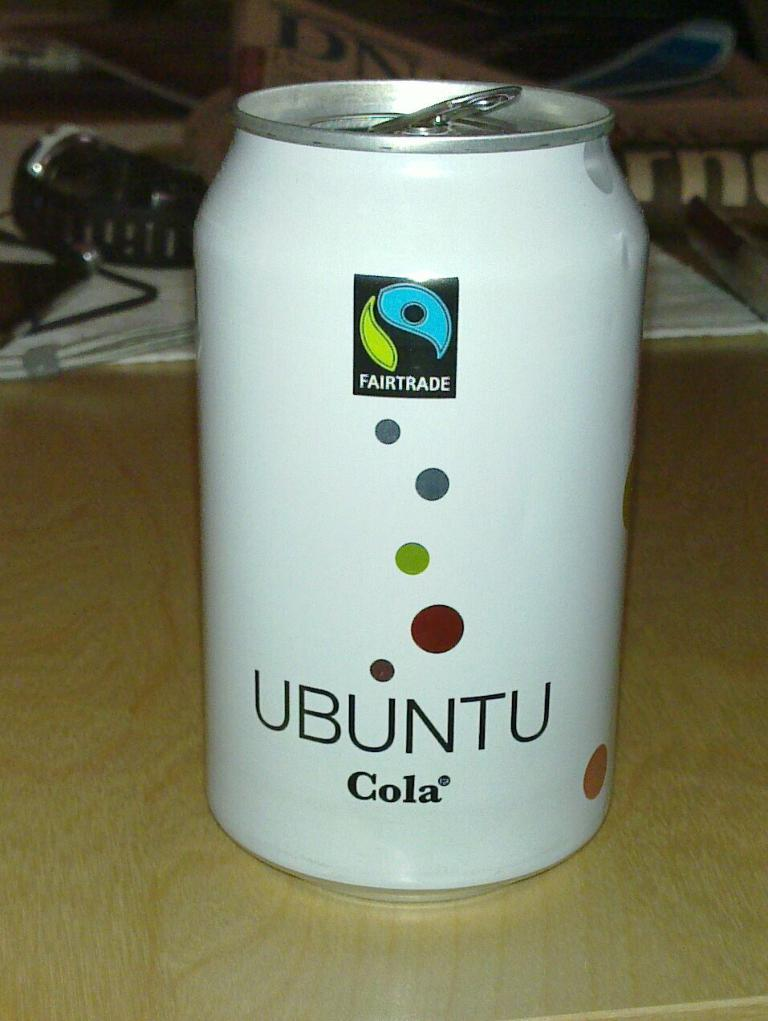<image>
Share a concise interpretation of the image provided. A white can that is opened of Fairtrade Ubuntu Cola. 